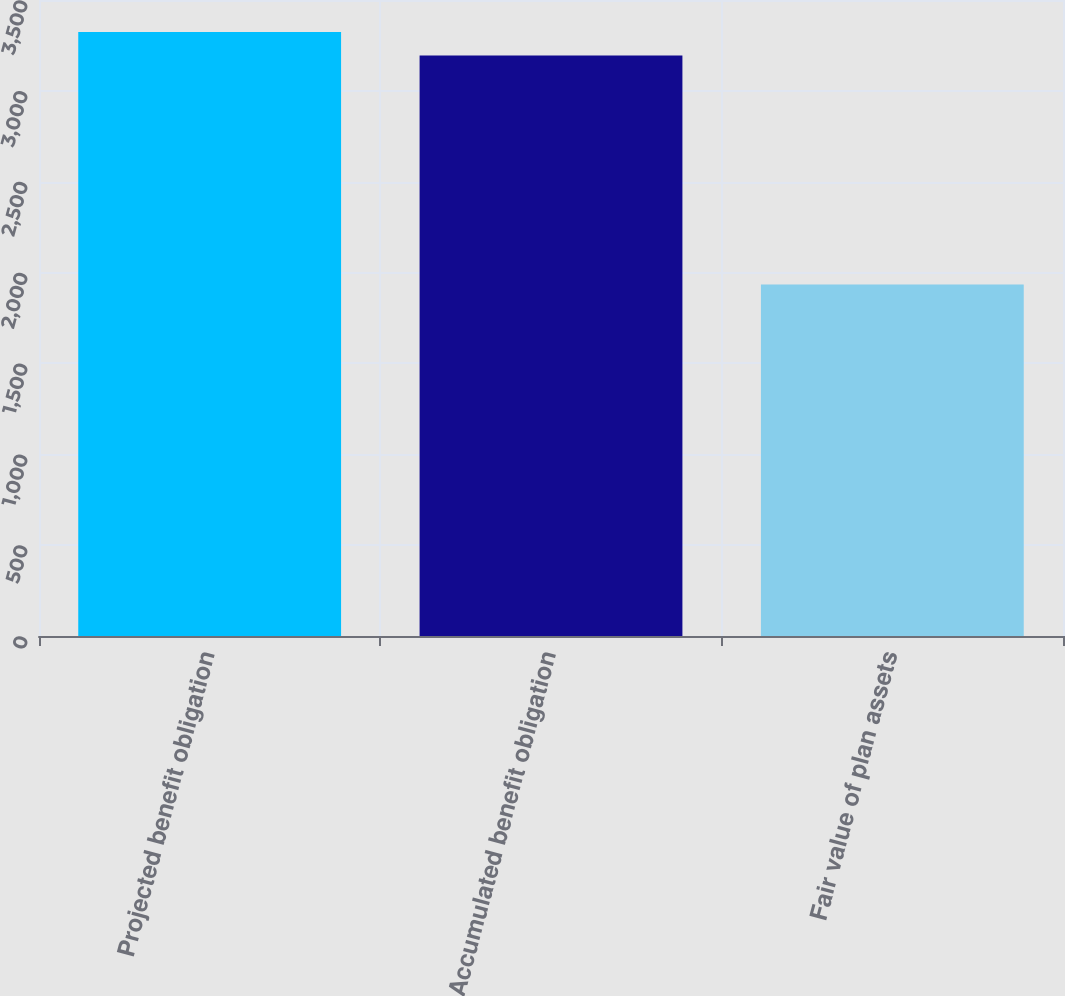Convert chart to OTSL. <chart><loc_0><loc_0><loc_500><loc_500><bar_chart><fcel>Projected benefit obligation<fcel>Accumulated benefit obligation<fcel>Fair value of plan assets<nl><fcel>3324.3<fcel>3195<fcel>1934<nl></chart> 